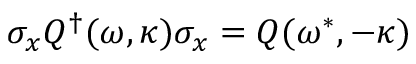Convert formula to latex. <formula><loc_0><loc_0><loc_500><loc_500>\sigma _ { x } Q ^ { \dagger } ( \omega , \kappa ) \sigma _ { x } = Q ( \omega ^ { * } , - \kappa )</formula> 